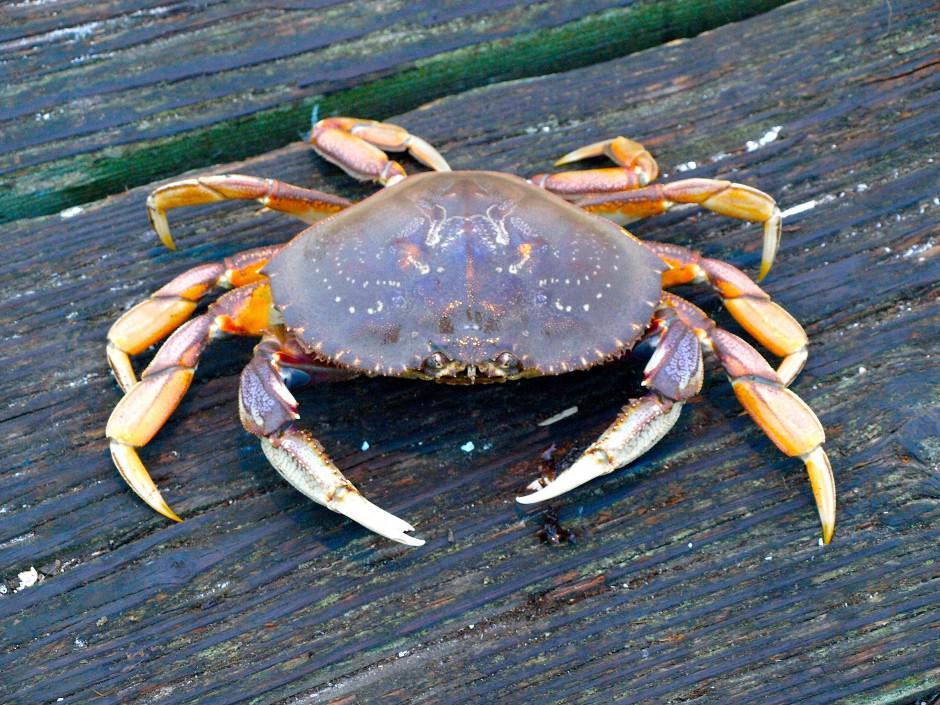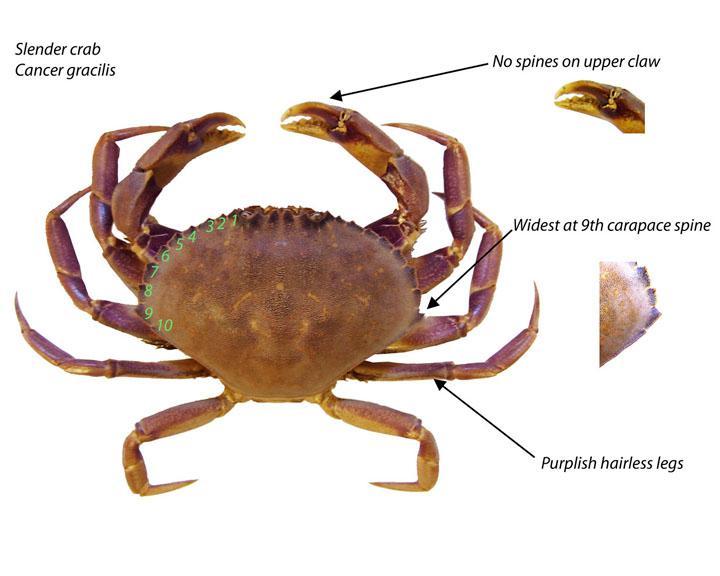The first image is the image on the left, the second image is the image on the right. Assess this claim about the two images: "Crabs are facing in opposite directions.". Correct or not? Answer yes or no. Yes. The first image is the image on the left, the second image is the image on the right. Assess this claim about the two images: "Each image is a from-the-top view of one crab, but one image shows a crab with its face and front claws on the top, and one shows them at the bottom.". Correct or not? Answer yes or no. Yes. 